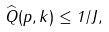<formula> <loc_0><loc_0><loc_500><loc_500>\widehat { Q } ( p , k ) \leq 1 / J ,</formula> 